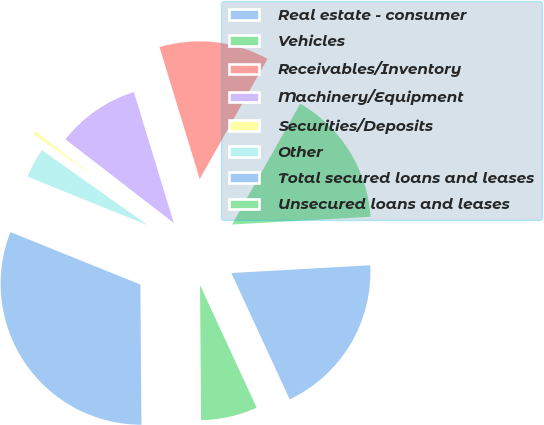Convert chart. <chart><loc_0><loc_0><loc_500><loc_500><pie_chart><fcel>Real estate - consumer<fcel>Vehicles<fcel>Receivables/Inventory<fcel>Machinery/Equipment<fcel>Securities/Deposits<fcel>Other<fcel>Total secured loans and leases<fcel>Unsecured loans and leases<nl><fcel>19.0%<fcel>15.94%<fcel>12.88%<fcel>9.82%<fcel>0.65%<fcel>3.71%<fcel>31.23%<fcel>6.77%<nl></chart> 